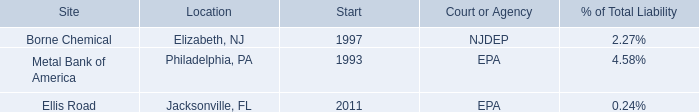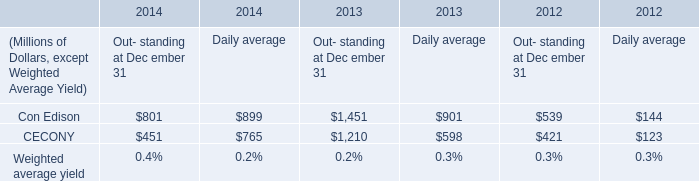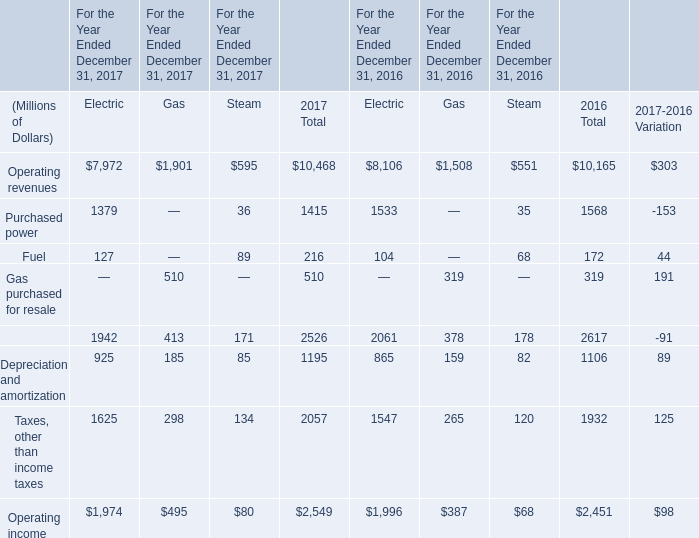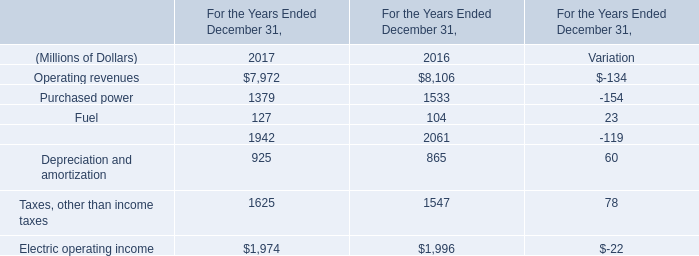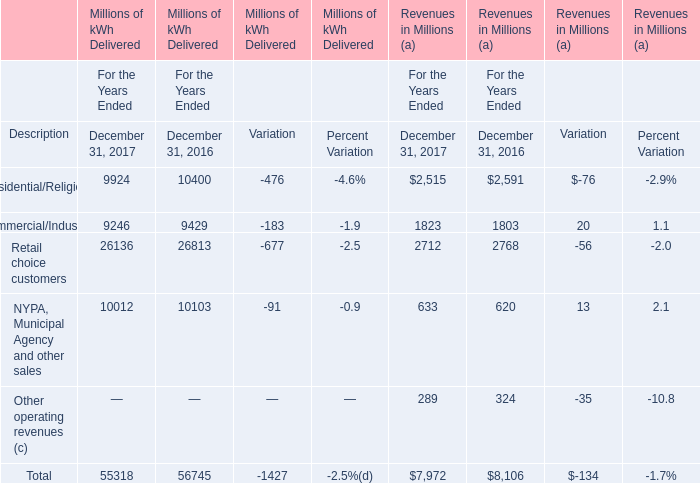How many kinds of element in 2017 are greater than those in the previous year? 
Answer: 3. 